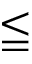<formula> <loc_0><loc_0><loc_500><loc_500>\leqq</formula> 